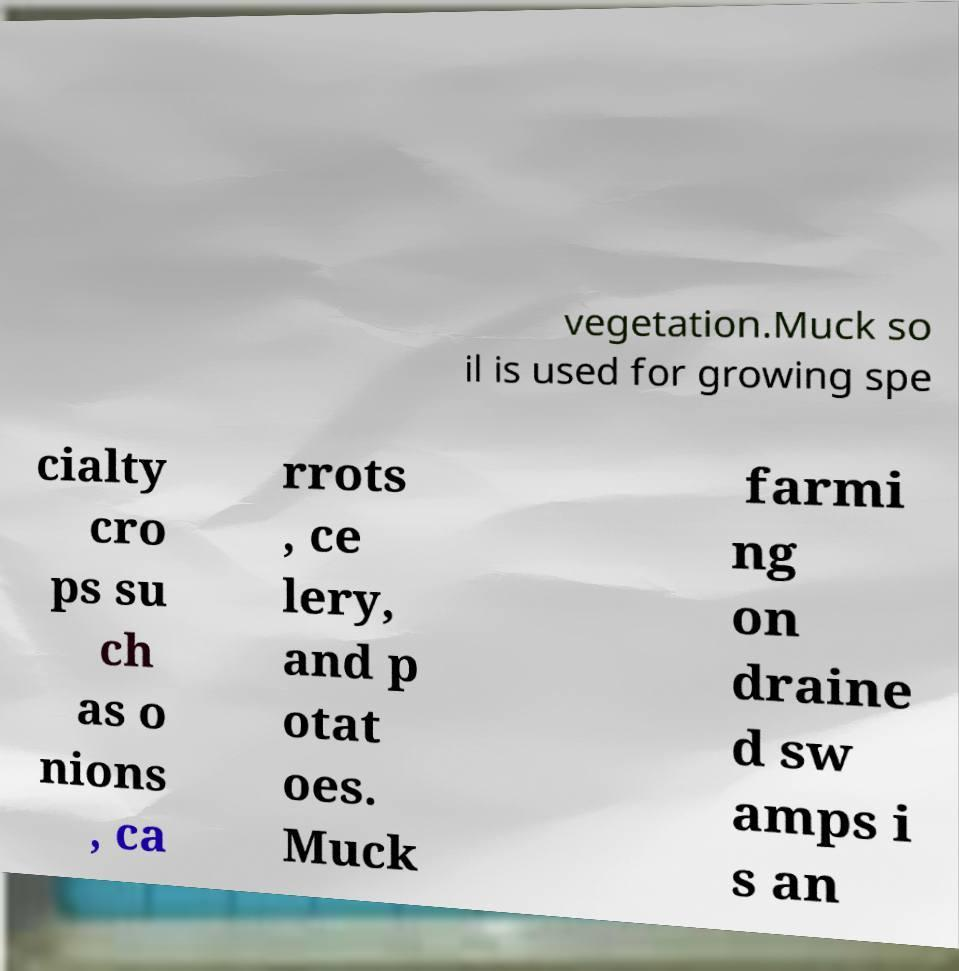I need the written content from this picture converted into text. Can you do that? vegetation.Muck so il is used for growing spe cialty cro ps su ch as o nions , ca rrots , ce lery, and p otat oes. Muck farmi ng on draine d sw amps i s an 